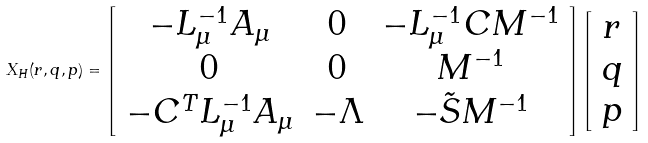<formula> <loc_0><loc_0><loc_500><loc_500>X _ { H } ( r , q , p ) = \left [ \begin{array} { c c c } - L _ { \mu } ^ { - 1 } A _ { \mu } & 0 & - L _ { \mu } ^ { - 1 } C M ^ { - 1 } \\ 0 & 0 & M ^ { - 1 } \\ - C ^ { T } L ^ { - 1 } _ { \mu } A _ { \mu } & - \Lambda & - \tilde { S } M ^ { - 1 } \end{array} \right ] \left [ \begin{array} { c } r \\ q \\ p \end{array} \right ]</formula> 